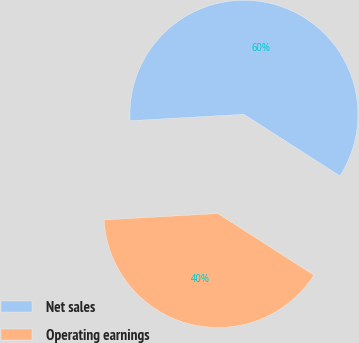<chart> <loc_0><loc_0><loc_500><loc_500><pie_chart><fcel>Net sales<fcel>Operating earnings<nl><fcel>59.97%<fcel>40.03%<nl></chart> 